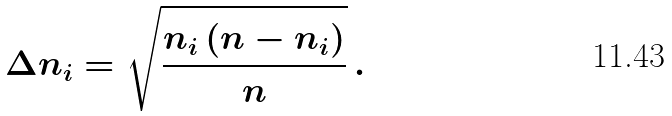Convert formula to latex. <formula><loc_0><loc_0><loc_500><loc_500>\Delta { n _ { i } } = \sqrt { \frac { n _ { i } \left ( n - n _ { i } \right ) } { n } } \, .</formula> 